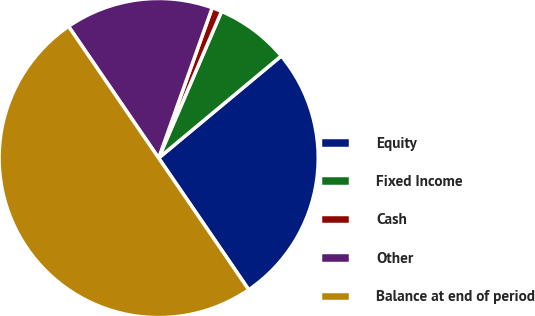Convert chart. <chart><loc_0><loc_0><loc_500><loc_500><pie_chart><fcel>Equity<fcel>Fixed Income<fcel>Cash<fcel>Other<fcel>Balance at end of period<nl><fcel>26.5%<fcel>7.5%<fcel>1.0%<fcel>15.0%<fcel>50.0%<nl></chart> 